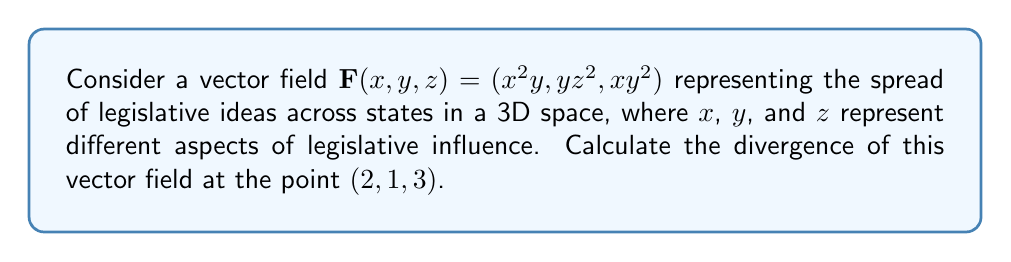What is the answer to this math problem? To solve this problem, we'll follow these steps:

1) The divergence of a vector field $\mathbf{F}(x, y, z) = (F_1, F_2, F_3)$ is given by:

   $$\nabla \cdot \mathbf{F} = \frac{\partial F_1}{\partial x} + \frac{\partial F_2}{\partial y} + \frac{\partial F_3}{\partial z}$$

2) For our vector field $\mathbf{F}(x, y, z) = (x^2y, yz^2, xy^2)$:
   
   $F_1 = x^2y$
   $F_2 = yz^2$
   $F_3 = xy^2$

3) Calculate the partial derivatives:

   $\frac{\partial F_1}{\partial x} = 2xy$
   
   $\frac{\partial F_2}{\partial y} = z^2$
   
   $\frac{\partial F_3}{\partial z} = 0$

4) Sum the partial derivatives:

   $$\nabla \cdot \mathbf{F} = 2xy + z^2 + 0 = 2xy + z^2$$

5) Evaluate at the point $(2, 1, 3)$:

   $$\nabla \cdot \mathbf{F}(2, 1, 3) = 2(2)(1) + 3^2 = 4 + 9 = 13$$

This result represents the rate at which legislative ideas are spreading or diverging at the given point in our abstract 3D space of legislative influence.
Answer: $13$ 